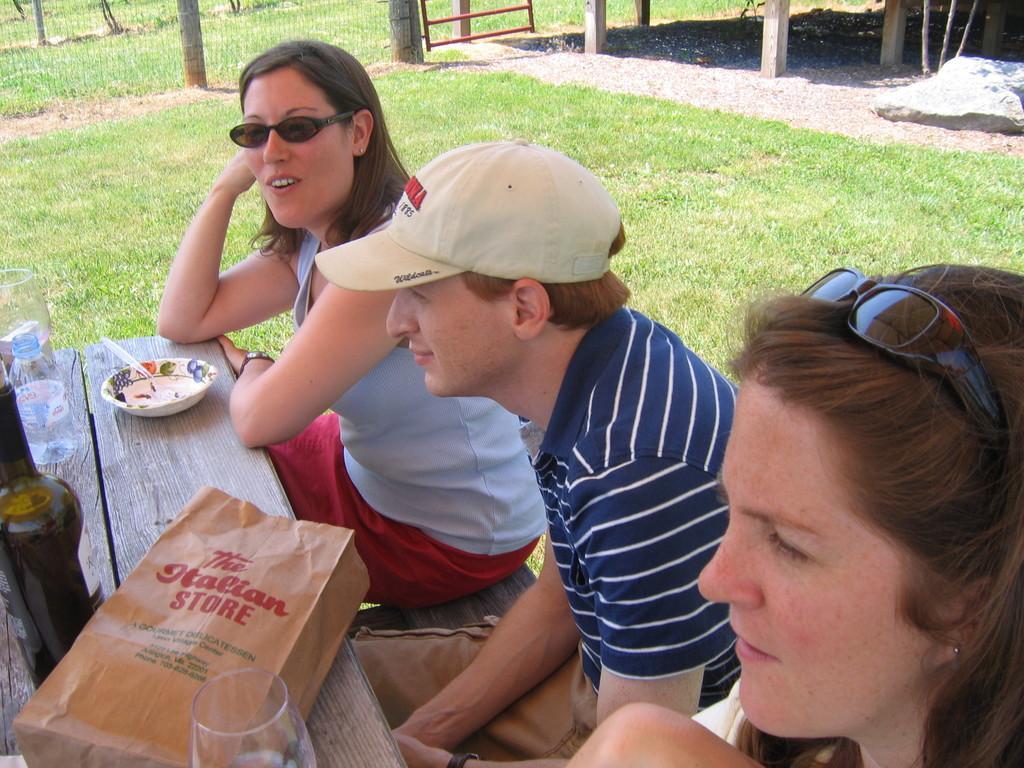Describe this image in one or two sentences. In the image we can see three persons were sitting on the bench. In front there is a table,on table we can see wine bottle,water bottle,glasses,bowl,spoon and paper cover. In the background there is a stone and grass. 